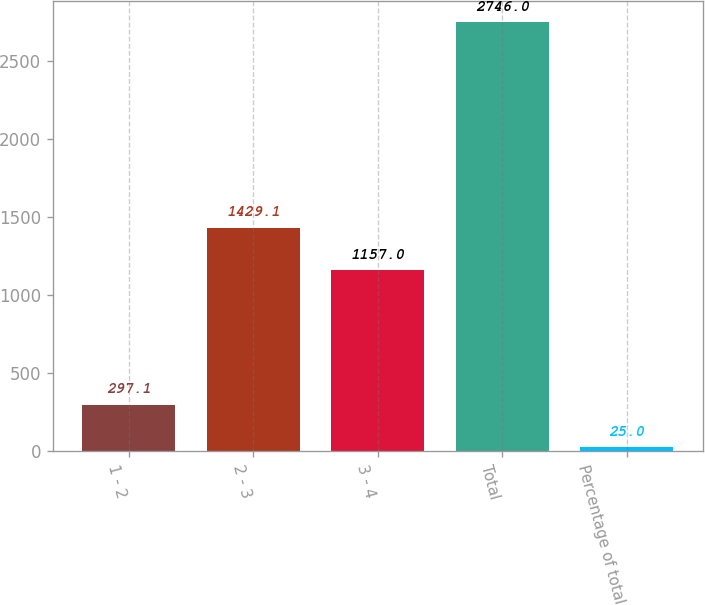<chart> <loc_0><loc_0><loc_500><loc_500><bar_chart><fcel>1 - 2<fcel>2 - 3<fcel>3 - 4<fcel>Total<fcel>Percentage of total<nl><fcel>297.1<fcel>1429.1<fcel>1157<fcel>2746<fcel>25<nl></chart> 